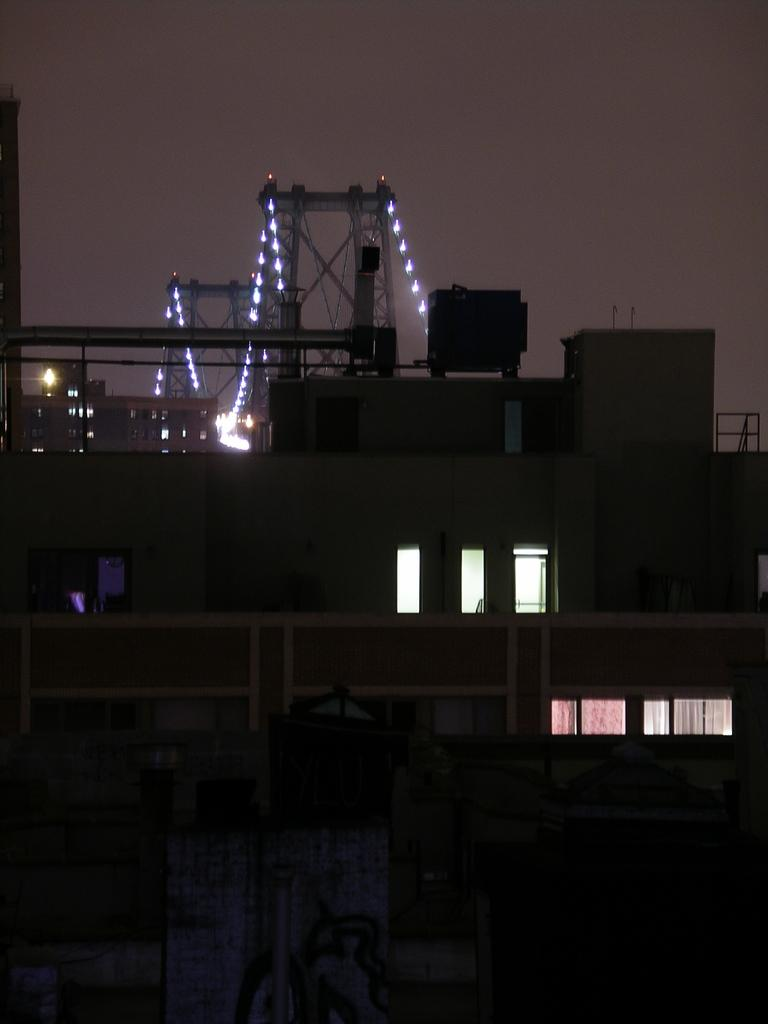What type of structures can be seen in the image? There are buildings in the image. What connects the two sides of the image? There is a bridge in the image. What can be seen illuminating the image? There are lights visible in the image. What is visible in the background of the image? The sky is visible in the background of the image. What type of sign can be seen on the bridge in the image? There is no sign visible on the bridge in the image. What type of cloud formation is present in the sky in the image? The provided facts do not mention any clouds in the sky, so we cannot determine the type of cloud formation. 